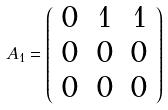Convert formula to latex. <formula><loc_0><loc_0><loc_500><loc_500>A _ { 1 } = \left ( \begin{array} { c c c } 0 & 1 & 1 \\ 0 & 0 & 0 \\ 0 & 0 & 0 \\ \end{array} \right )</formula> 